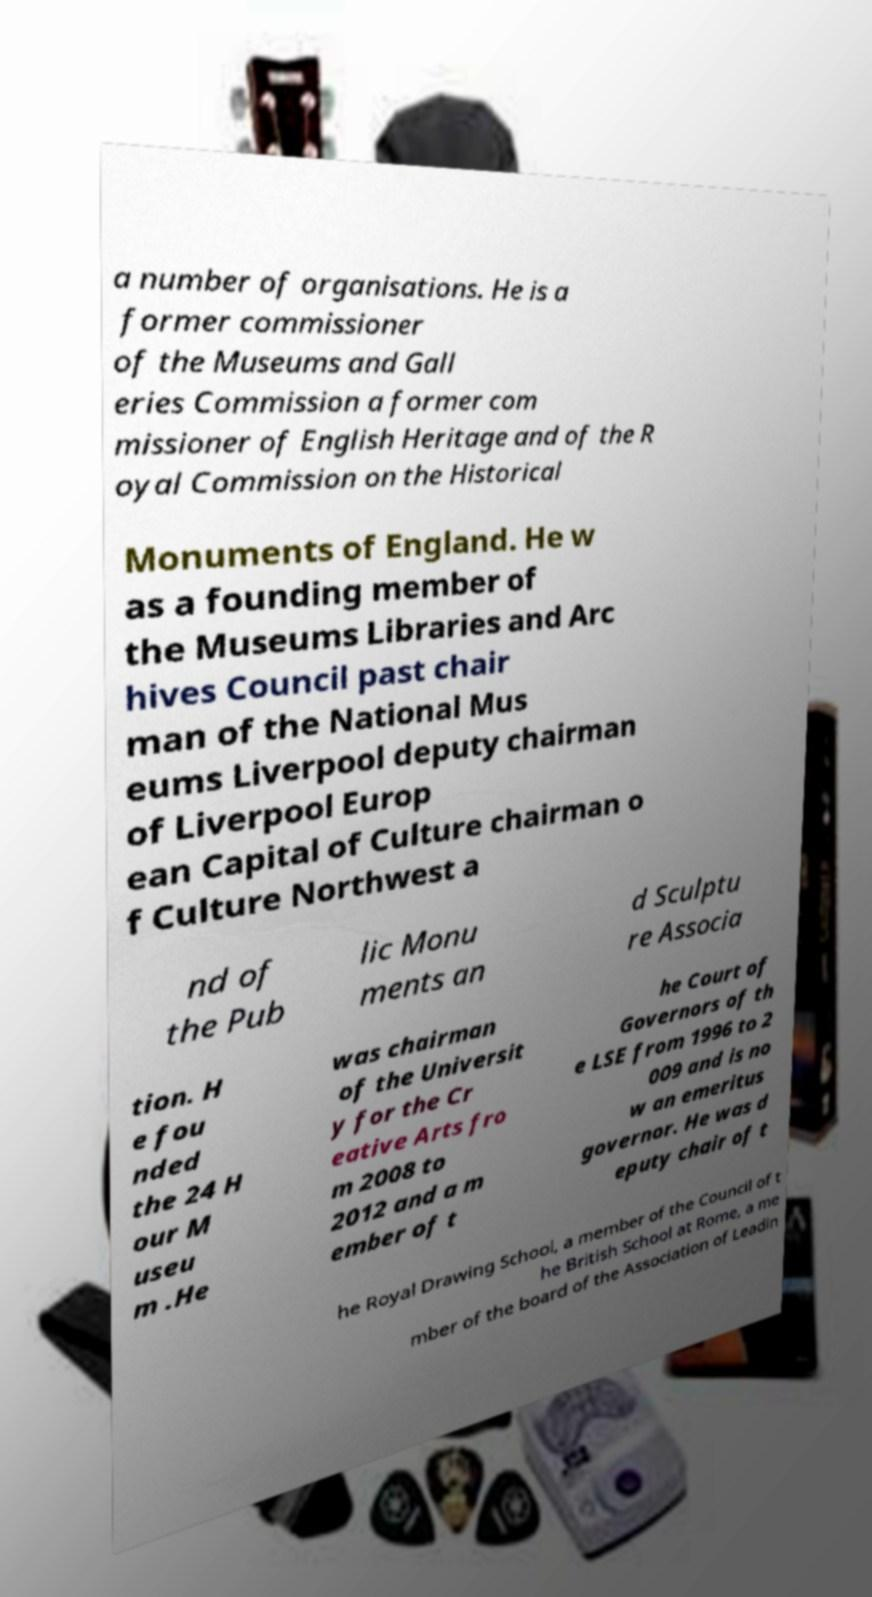Can you read and provide the text displayed in the image?This photo seems to have some interesting text. Can you extract and type it out for me? a number of organisations. He is a former commissioner of the Museums and Gall eries Commission a former com missioner of English Heritage and of the R oyal Commission on the Historical Monuments of England. He w as a founding member of the Museums Libraries and Arc hives Council past chair man of the National Mus eums Liverpool deputy chairman of Liverpool Europ ean Capital of Culture chairman o f Culture Northwest a nd of the Pub lic Monu ments an d Sculptu re Associa tion. H e fou nded the 24 H our M useu m .He was chairman of the Universit y for the Cr eative Arts fro m 2008 to 2012 and a m ember of t he Court of Governors of th e LSE from 1996 to 2 009 and is no w an emeritus governor. He was d eputy chair of t he Royal Drawing School, a member of the Council of t he British School at Rome, a me mber of the board of the Association of Leadin 